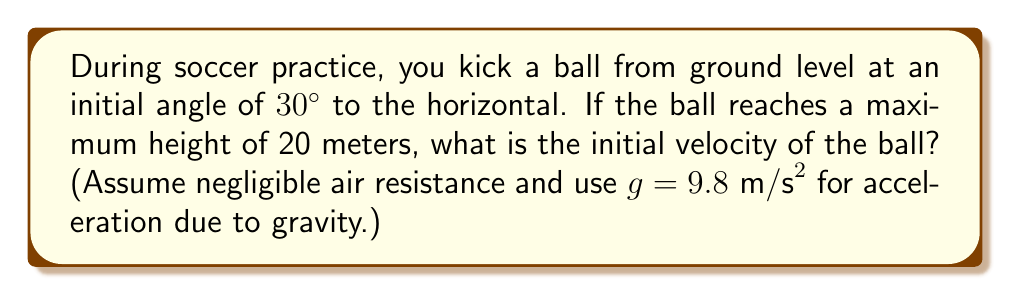Can you answer this question? Let's approach this step-by-step:

1) In projectile motion, the maximum height (h) is given by the equation:

   $h = \frac{v_0^2 \sin^2 \theta}{2g}$

   Where $v_0$ is the initial velocity, $\theta$ is the launch angle, and g is the acceleration due to gravity.

2) We're given:
   $h = 20$ meters
   $\theta = 30°$
   $g = 9.8$ m/s²

3) Let's substitute these into our equation:

   $20 = \frac{v_0^2 \sin^2 30°}{2(9.8)}$

4) Simplify $\sin 30°$:
   $\sin 30° = 0.5$

5) Substitute this:

   $20 = \frac{v_0^2 (0.5)^2}{2(9.8)}$

6) Simplify:

   $20 = \frac{v_0^2 (0.25)}{19.6}$

7) Multiply both sides by 19.6:

   $392 = 0.25v_0^2$

8) Multiply both sides by 4:

   $1568 = v_0^2$

9) Take the square root of both sides:

   $v_0 = \sqrt{1568} \approx 39.6$ m/s
Answer: 39.6 m/s 